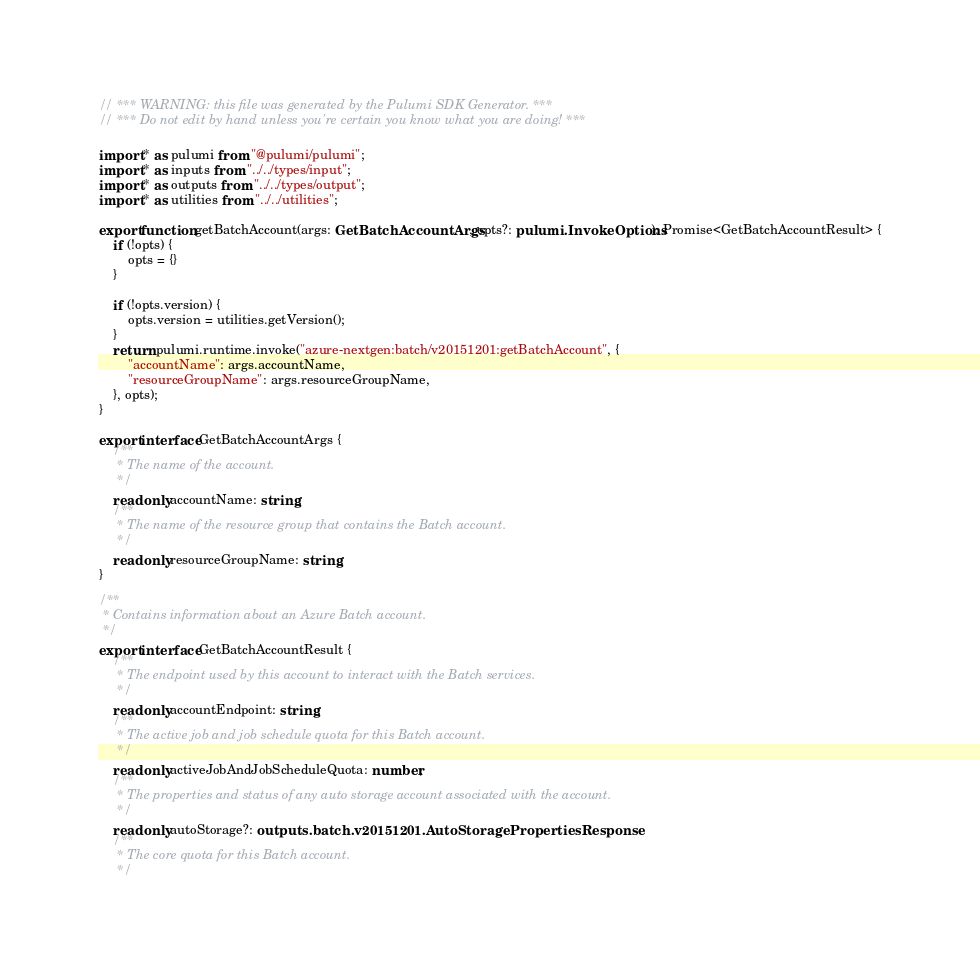Convert code to text. <code><loc_0><loc_0><loc_500><loc_500><_TypeScript_>// *** WARNING: this file was generated by the Pulumi SDK Generator. ***
// *** Do not edit by hand unless you're certain you know what you are doing! ***

import * as pulumi from "@pulumi/pulumi";
import * as inputs from "../../types/input";
import * as outputs from "../../types/output";
import * as utilities from "../../utilities";

export function getBatchAccount(args: GetBatchAccountArgs, opts?: pulumi.InvokeOptions): Promise<GetBatchAccountResult> {
    if (!opts) {
        opts = {}
    }

    if (!opts.version) {
        opts.version = utilities.getVersion();
    }
    return pulumi.runtime.invoke("azure-nextgen:batch/v20151201:getBatchAccount", {
        "accountName": args.accountName,
        "resourceGroupName": args.resourceGroupName,
    }, opts);
}

export interface GetBatchAccountArgs {
    /**
     * The name of the account.
     */
    readonly accountName: string;
    /**
     * The name of the resource group that contains the Batch account.
     */
    readonly resourceGroupName: string;
}

/**
 * Contains information about an Azure Batch account.
 */
export interface GetBatchAccountResult {
    /**
     * The endpoint used by this account to interact with the Batch services.
     */
    readonly accountEndpoint: string;
    /**
     * The active job and job schedule quota for this Batch account.
     */
    readonly activeJobAndJobScheduleQuota: number;
    /**
     * The properties and status of any auto storage account associated with the account.
     */
    readonly autoStorage?: outputs.batch.v20151201.AutoStoragePropertiesResponse;
    /**
     * The core quota for this Batch account.
     */</code> 